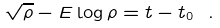<formula> <loc_0><loc_0><loc_500><loc_500>\sqrt { \rho } - E \log \rho = t - t _ { 0 } \ .</formula> 